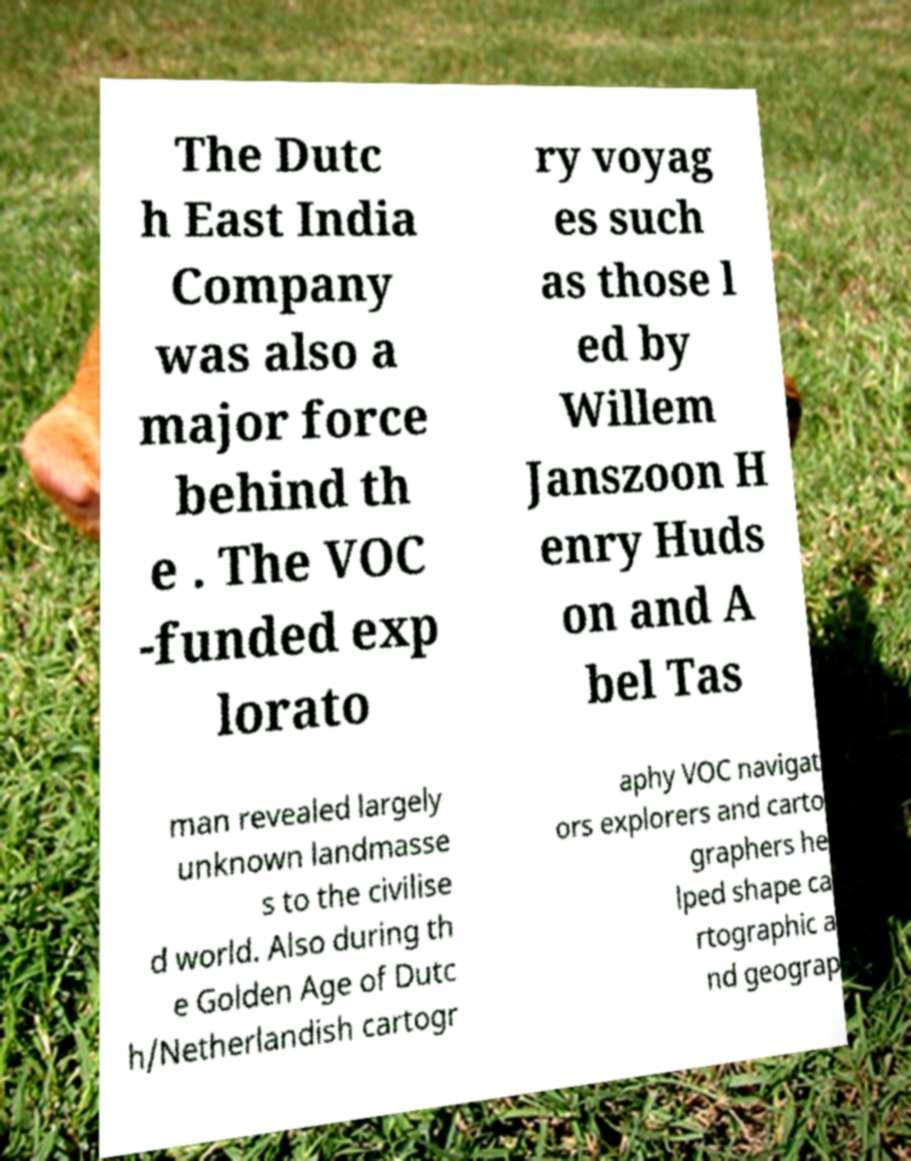Could you assist in decoding the text presented in this image and type it out clearly? The Dutc h East India Company was also a major force behind th e . The VOC -funded exp lorato ry voyag es such as those l ed by Willem Janszoon H enry Huds on and A bel Tas man revealed largely unknown landmasse s to the civilise d world. Also during th e Golden Age of Dutc h/Netherlandish cartogr aphy VOC navigat ors explorers and carto graphers he lped shape ca rtographic a nd geograp 